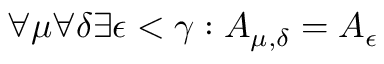<formula> <loc_0><loc_0><loc_500><loc_500>\forall \mu \forall \delta \exists \epsilon < \gamma \colon A _ { \mu , \delta } = A _ { \epsilon }</formula> 